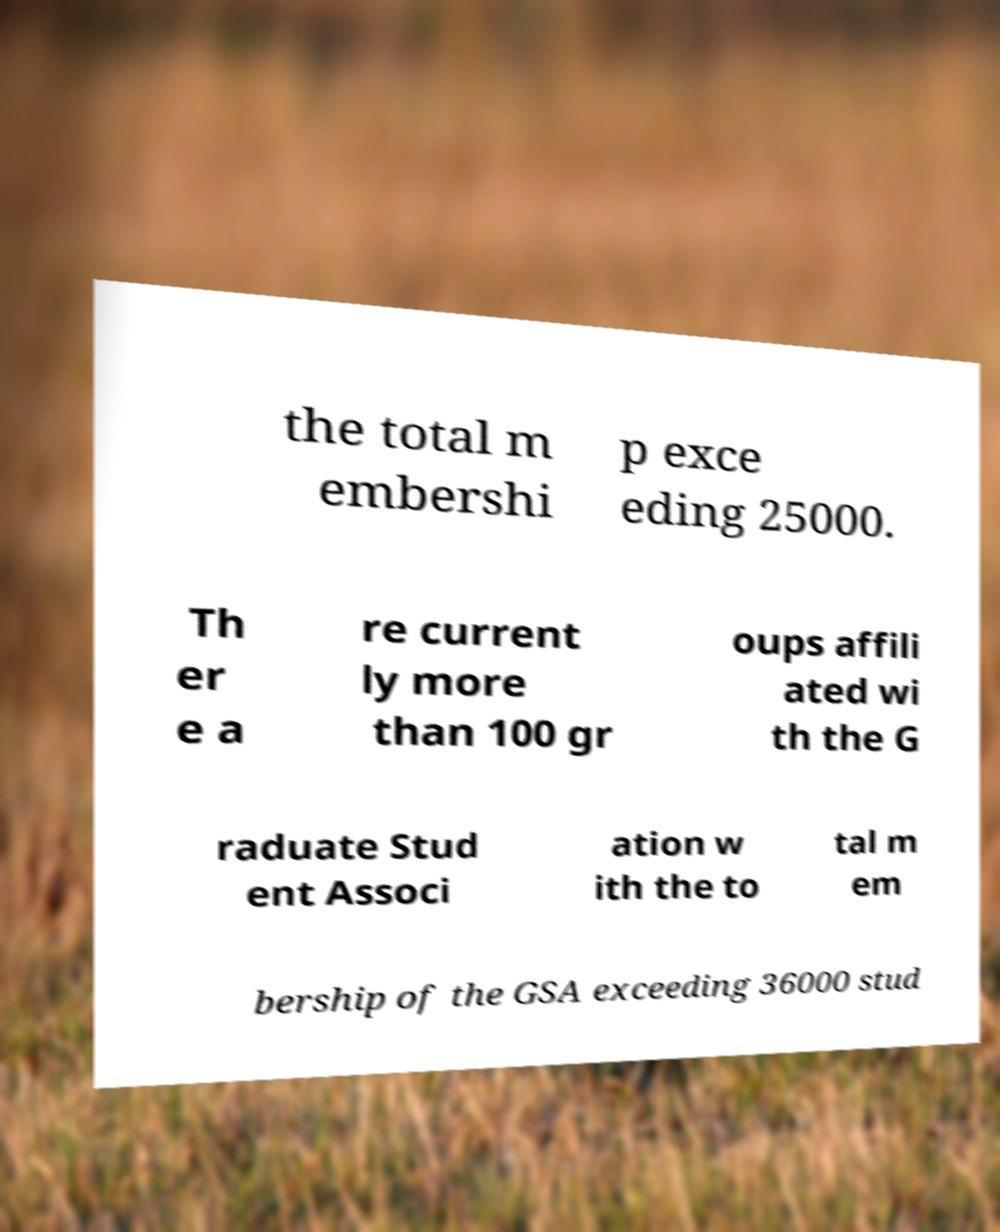Can you read and provide the text displayed in the image?This photo seems to have some interesting text. Can you extract and type it out for me? the total m embershi p exce eding 25000. Th er e a re current ly more than 100 gr oups affili ated wi th the G raduate Stud ent Associ ation w ith the to tal m em bership of the GSA exceeding 36000 stud 